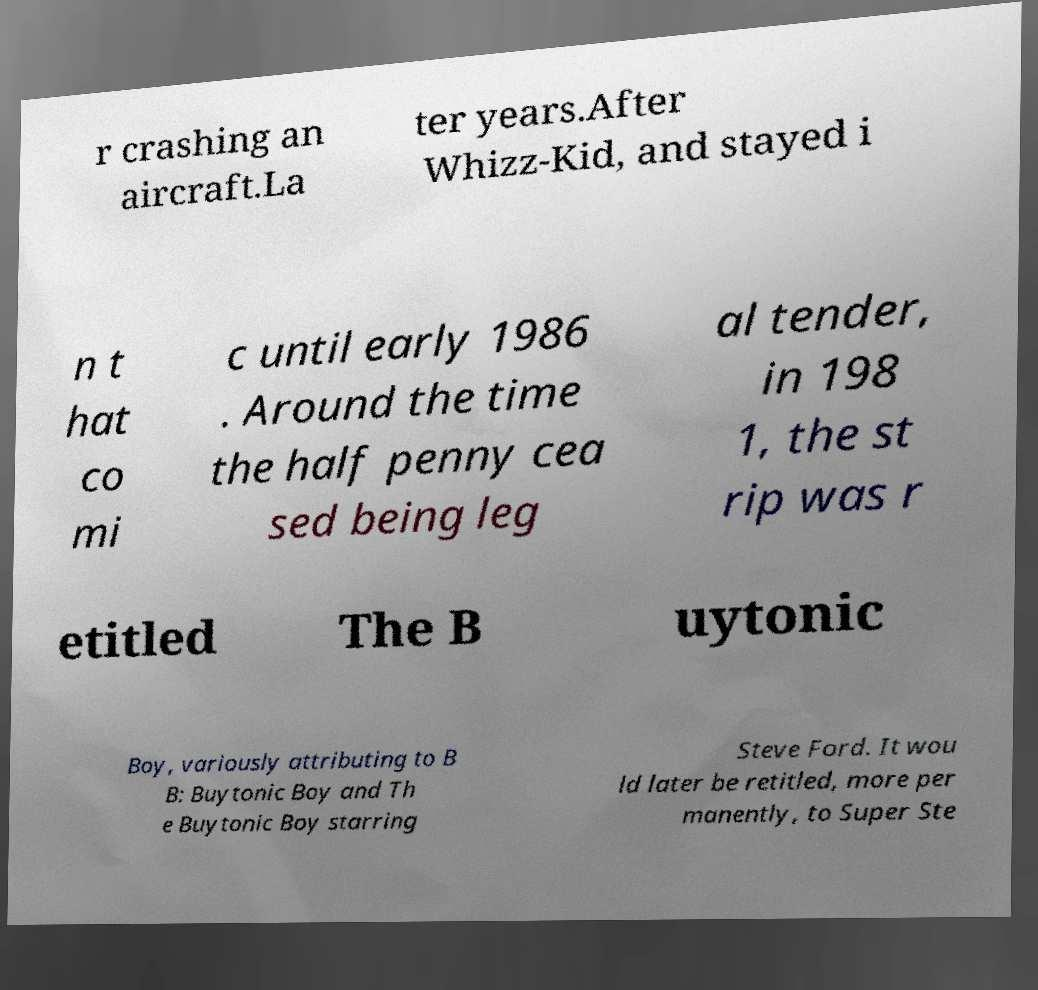For documentation purposes, I need the text within this image transcribed. Could you provide that? r crashing an aircraft.La ter years.After Whizz-Kid, and stayed i n t hat co mi c until early 1986 . Around the time the half penny cea sed being leg al tender, in 198 1, the st rip was r etitled The B uytonic Boy, variously attributing to B B: Buytonic Boy and Th e Buytonic Boy starring Steve Ford. It wou ld later be retitled, more per manently, to Super Ste 